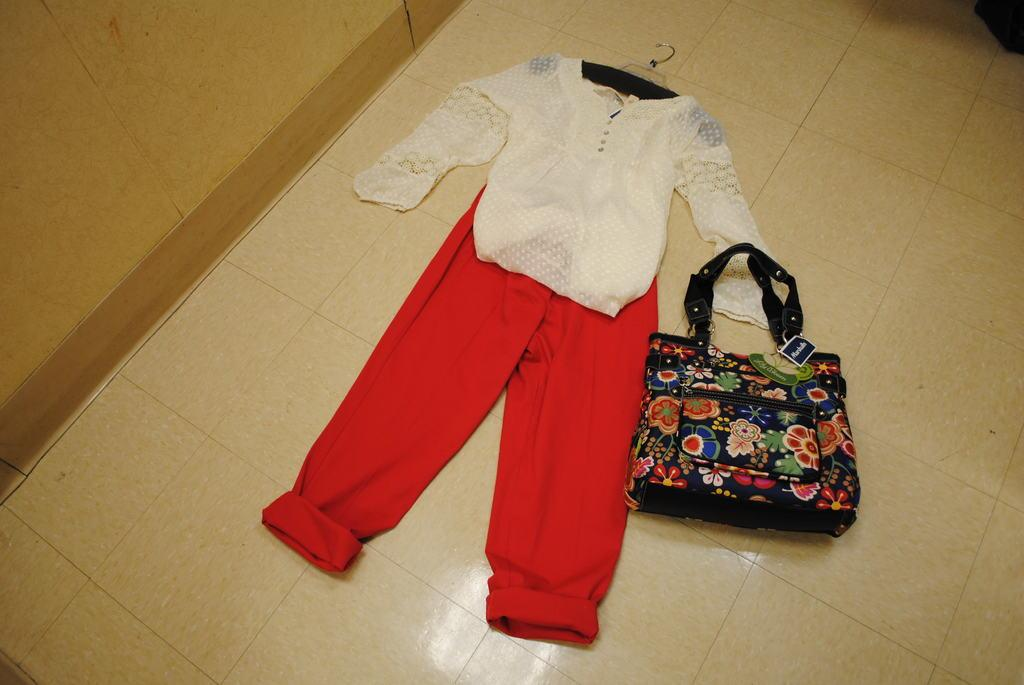What is placed on the floor in the image? There is a dress on the floor in the image. Is there anything else placed beside the dress on the floor? Yes, there is a handbag beside the dress on the floor. What can be seen on the left side of the image? There is a wall on the left side of the image. What type of voice can be heard coming from the dress in the image? There is no voice coming from the dress in the image, as it is an inanimate object. 